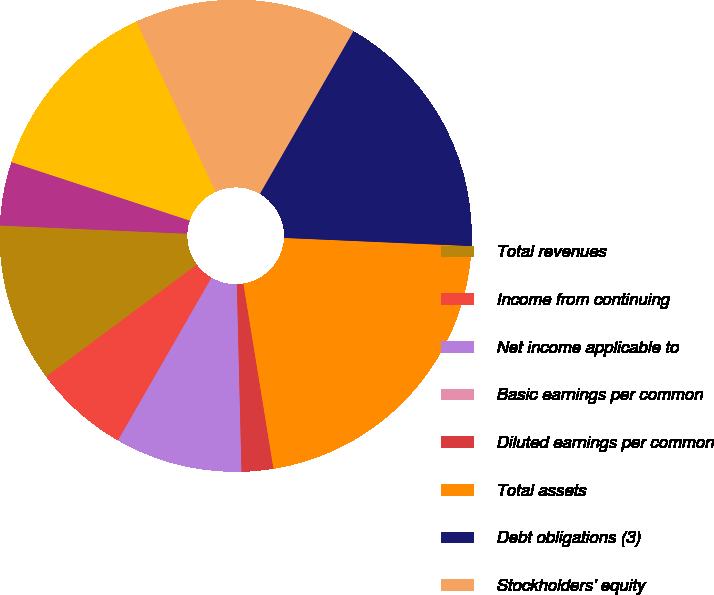Convert chart. <chart><loc_0><loc_0><loc_500><loc_500><pie_chart><fcel>Total revenues<fcel>Income from continuing<fcel>Net income applicable to<fcel>Basic earnings per common<fcel>Diluted earnings per common<fcel>Total assets<fcel>Debt obligations (3)<fcel>Stockholders' equity<fcel>Dividends paid<fcel>Dividends paid per common<nl><fcel>10.87%<fcel>6.52%<fcel>8.7%<fcel>0.0%<fcel>2.17%<fcel>21.74%<fcel>17.39%<fcel>15.22%<fcel>13.04%<fcel>4.35%<nl></chart> 